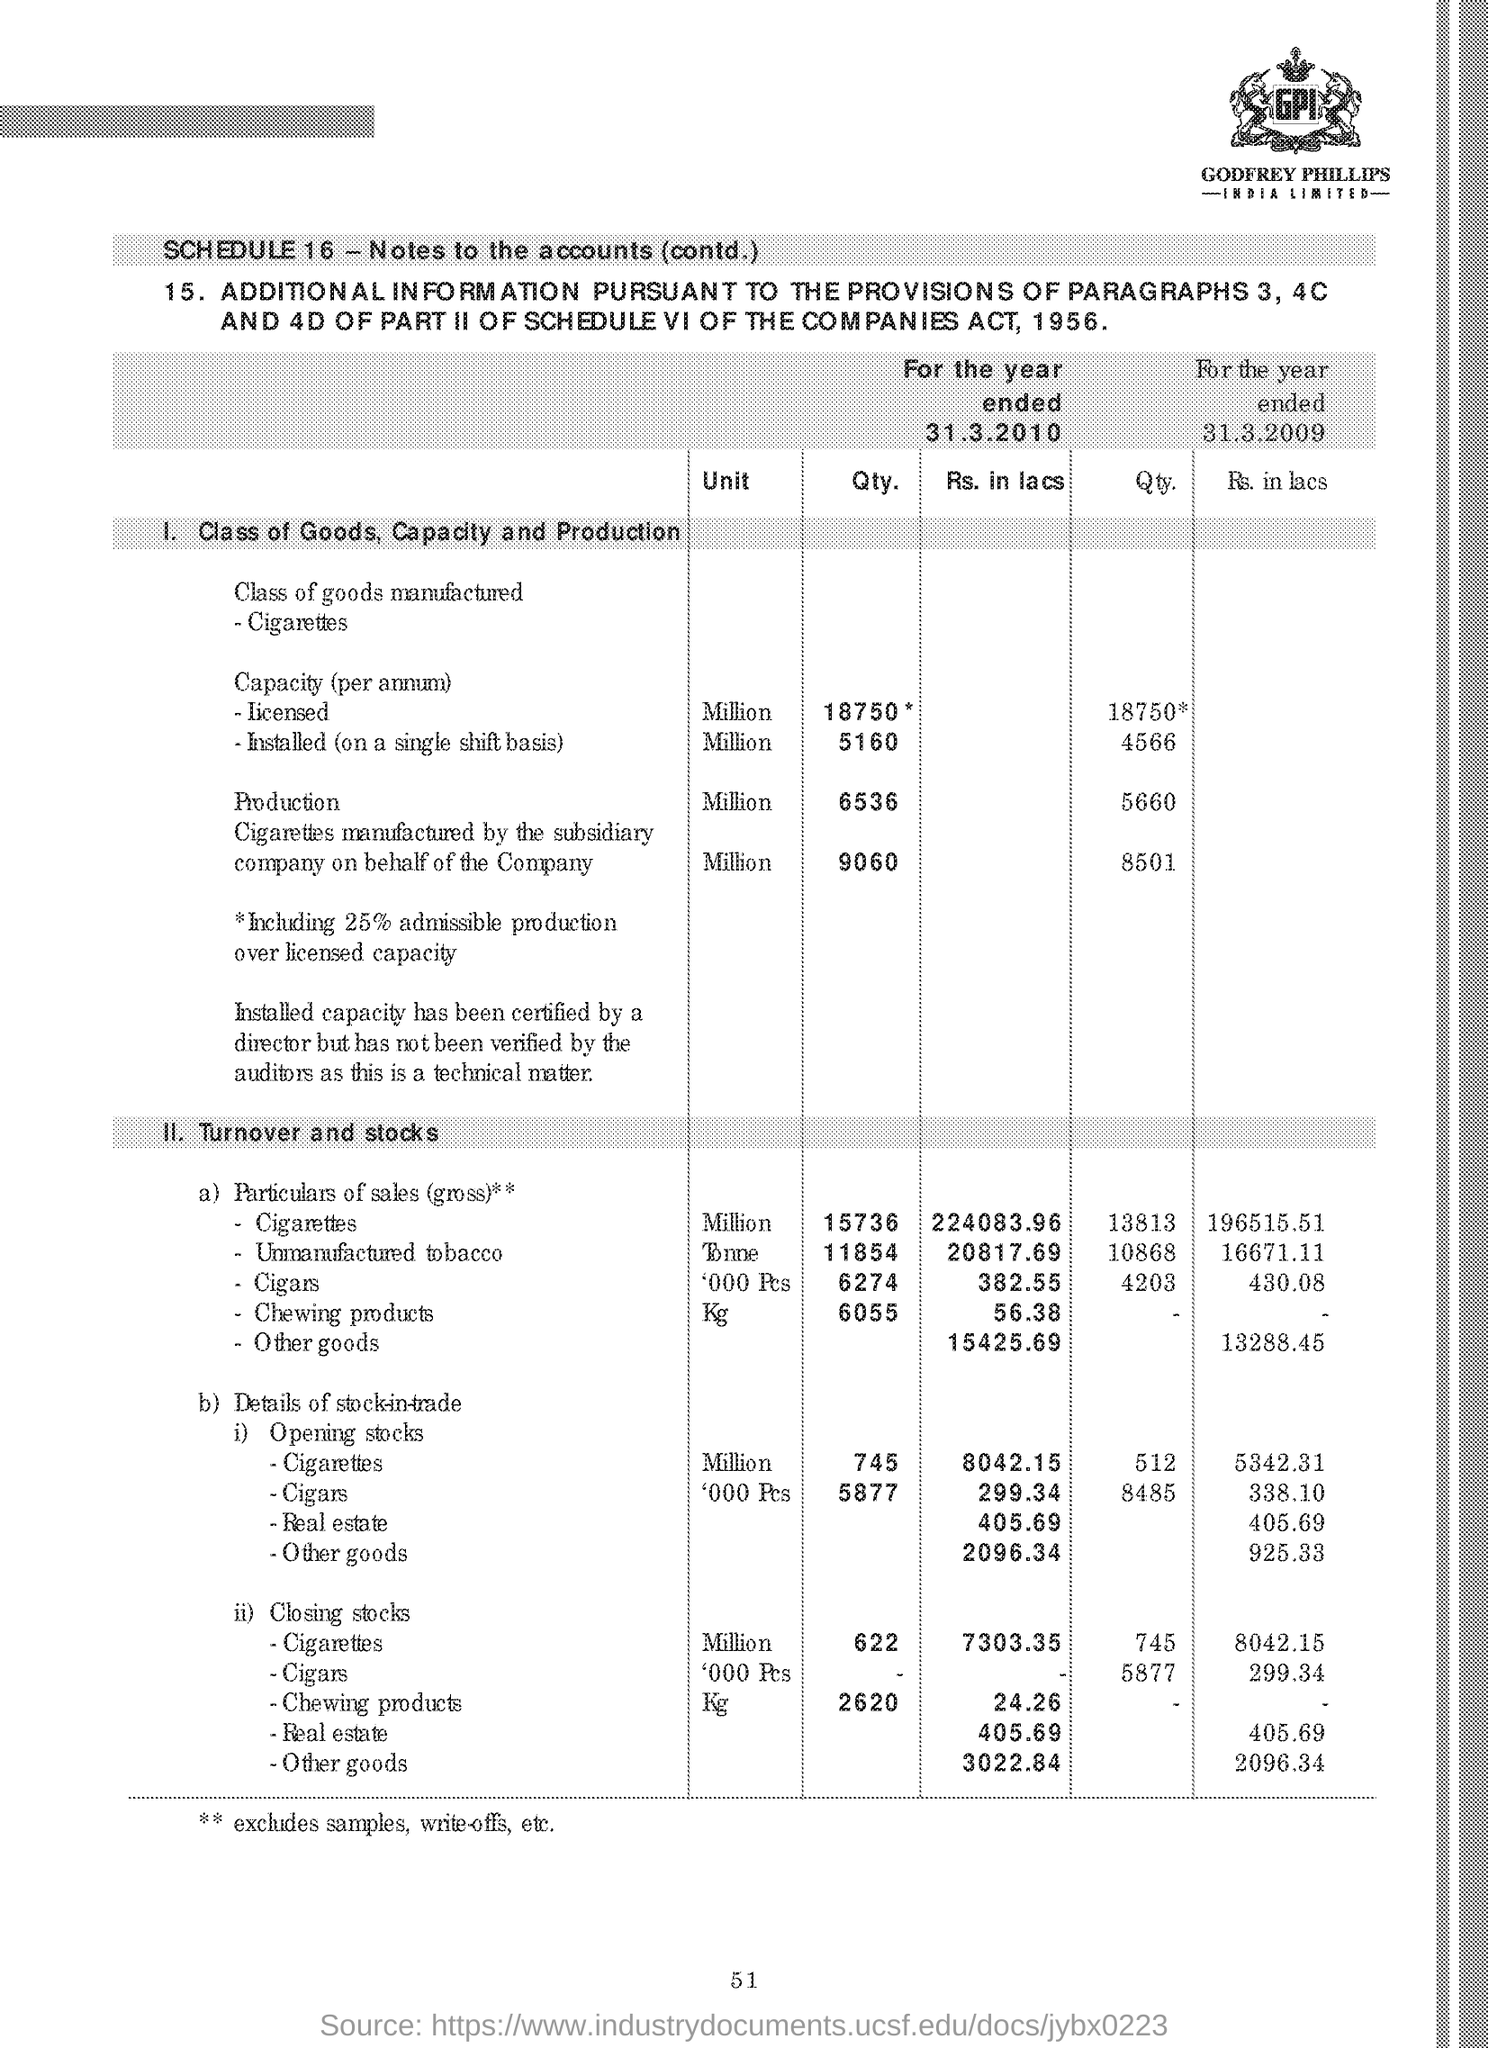Point out several critical features in this image. The unit specified for Qty. under the subheading '1.Class of Goods, Capacity and Production' is million. The page number given at the footer is 51. The quantity of closing stocks of cigarettes for the year 31st March 2010, based on subheading II. Turnover and stocks, is 622.. The symbol '**' denotes the exclusion of samples and write-offs at the end of the document. The quantity of Licensed Capacity (per annum) for the year ended March 31, 2010 was 18,750. 